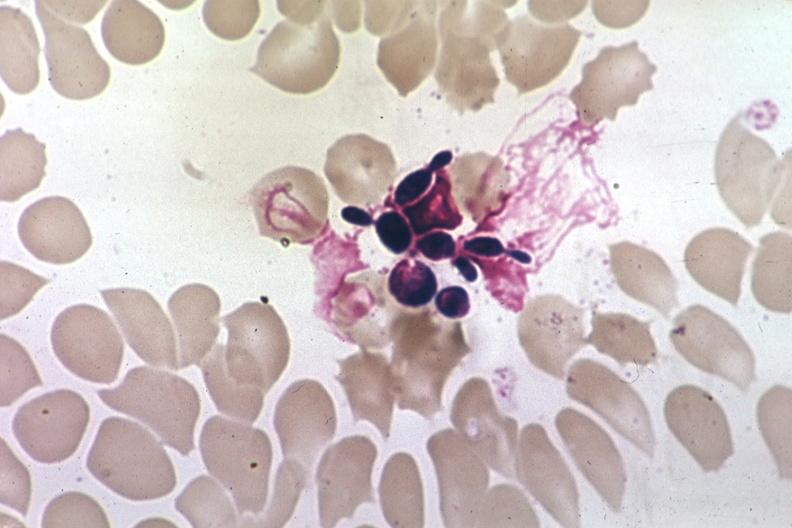s blood present?
Answer the question using a single word or phrase. Yes 